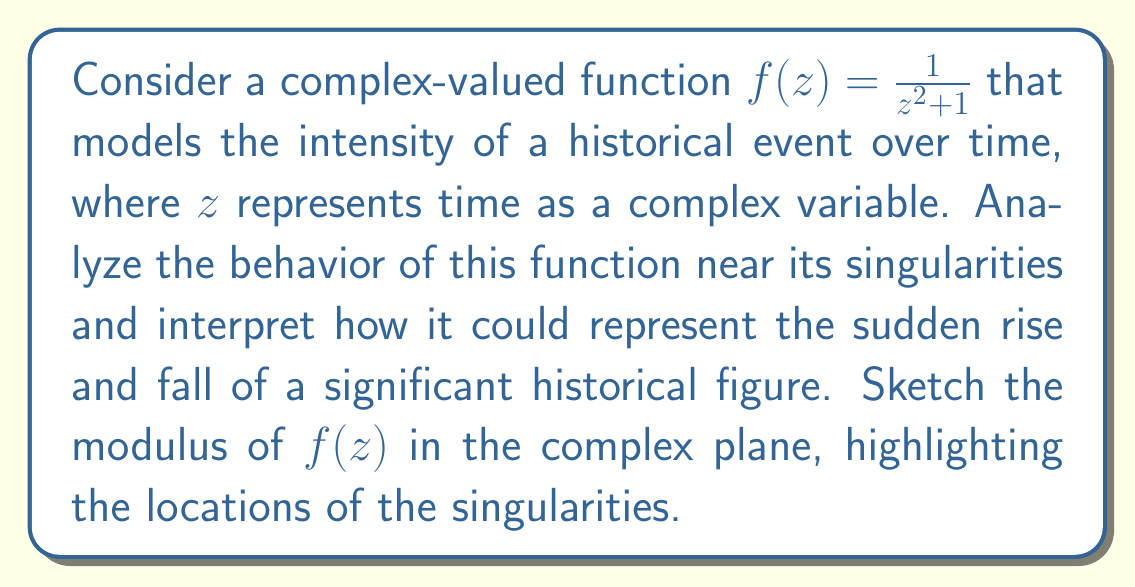What is the answer to this math problem? To analyze the behavior of $f(z) = \frac{1}{z^2 + 1}$ near its singularities, we need to:

1. Find the singularities:
   The singularities occur when the denominator is zero:
   $z^2 + 1 = 0$
   $z = \pm i$

   So, the function has two simple poles at $z = i$ and $z = -i$.

2. Analyze the behavior near these singularities:
   As $z$ approaches either $i$ or $-i$, the denominator approaches zero, causing the function to approach infinity.

3. Interpret the historical significance:
   The sudden rise to infinity near the singularities could represent a rapid increase in the historical figure's influence or power. The symmetry of the two poles might represent two pivotal moments in the figure's life or career.

4. Sketch the modulus of $f(z)$:
   The modulus of $f(z)$ is given by:
   $$|f(z)| = \frac{1}{|z^2 + 1|}$$

   This creates a surface with two sharp peaks at $z = i$ and $z = -i$, representing the rapid rise in intensity at these points.

[asy]
import graph3;
import palette;

size(200,200,IgnoreAspect);
currentprojection=orthographic(4,4,2);

real f(pair z) {return 1/abs(z^2+1);}

surface s=surface(f,(-2,-2),(2,2),50,Spline);

draw(s,palegreen,lightgreen+opacity(.7),AXISPEN);

xaxis3("Re(z)",-2,2,blue,Arrow3);
yaxis3("Im(z)",-2,2,blue,Arrow3);
zaxis3("$|f(z)|$",0,1.5,blue,Arrow3);

dot((0,1,0),red);
dot((0,-1,0),red);
label("$i$",(0,1,0),E);
label("$-i$",(0,-1,0),W);
[/asy]

This visualization shows how the function's magnitude spikes dramatically near the singularities, which could be interpreted as sudden, intense moments in the historical narrative.
Answer: The function $f(z) = \frac{1}{z^2 + 1}$ has two simple poles at $z = i$ and $z = -i$. Near these singularities, the function's magnitude approaches infinity, which can be interpreted as pivotal moments of extreme intensity in a historical narrative. The modulus of $f(z)$ forms a surface with two sharp peaks at these points, visually representing the sudden rise and fall of a historical figure's influence or power. 